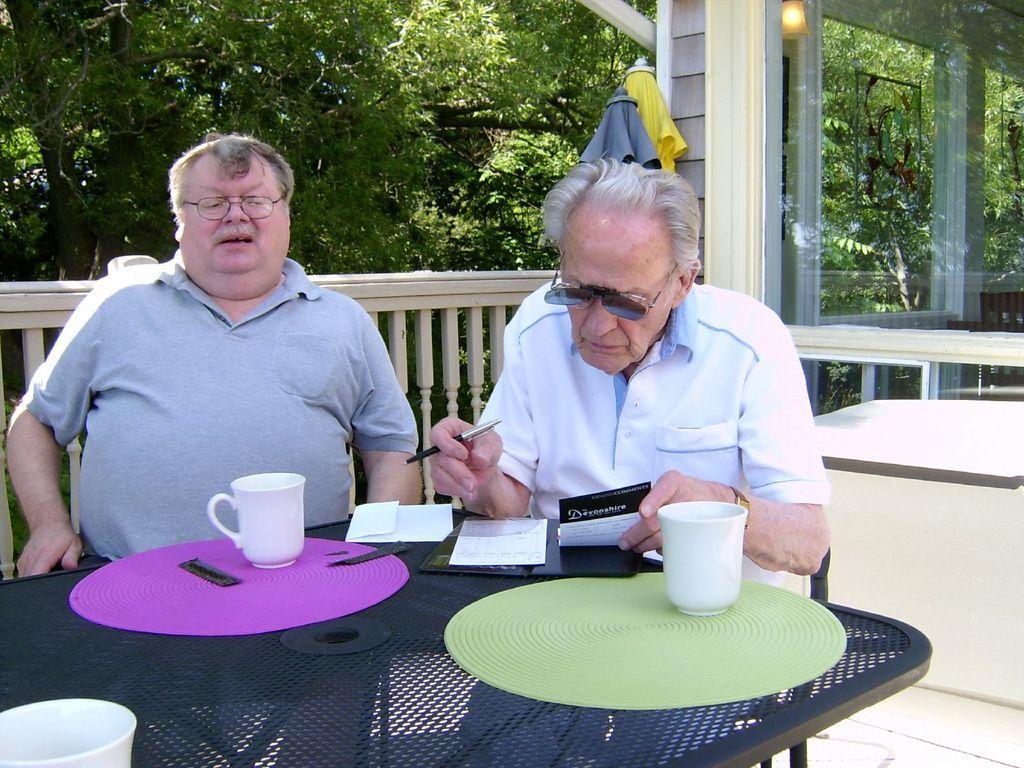Could you give a brief overview of what you see in this image? In this image I see 2 men, who are sitting on chairs and this man is holding a pen and paper. I can also see there is a table in front of them, on which there are 2 papers and 3 cups. In the background I see the trees, light and the fence. 